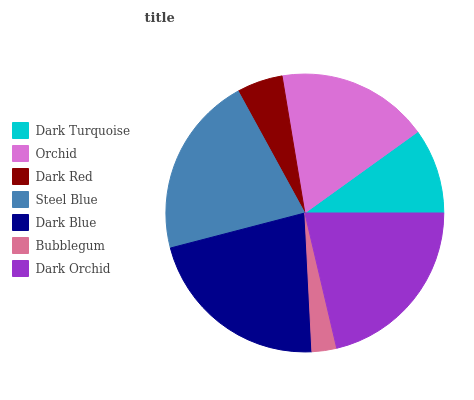Is Bubblegum the minimum?
Answer yes or no. Yes. Is Dark Blue the maximum?
Answer yes or no. Yes. Is Orchid the minimum?
Answer yes or no. No. Is Orchid the maximum?
Answer yes or no. No. Is Orchid greater than Dark Turquoise?
Answer yes or no. Yes. Is Dark Turquoise less than Orchid?
Answer yes or no. Yes. Is Dark Turquoise greater than Orchid?
Answer yes or no. No. Is Orchid less than Dark Turquoise?
Answer yes or no. No. Is Orchid the high median?
Answer yes or no. Yes. Is Orchid the low median?
Answer yes or no. Yes. Is Dark Turquoise the high median?
Answer yes or no. No. Is Dark Red the low median?
Answer yes or no. No. 